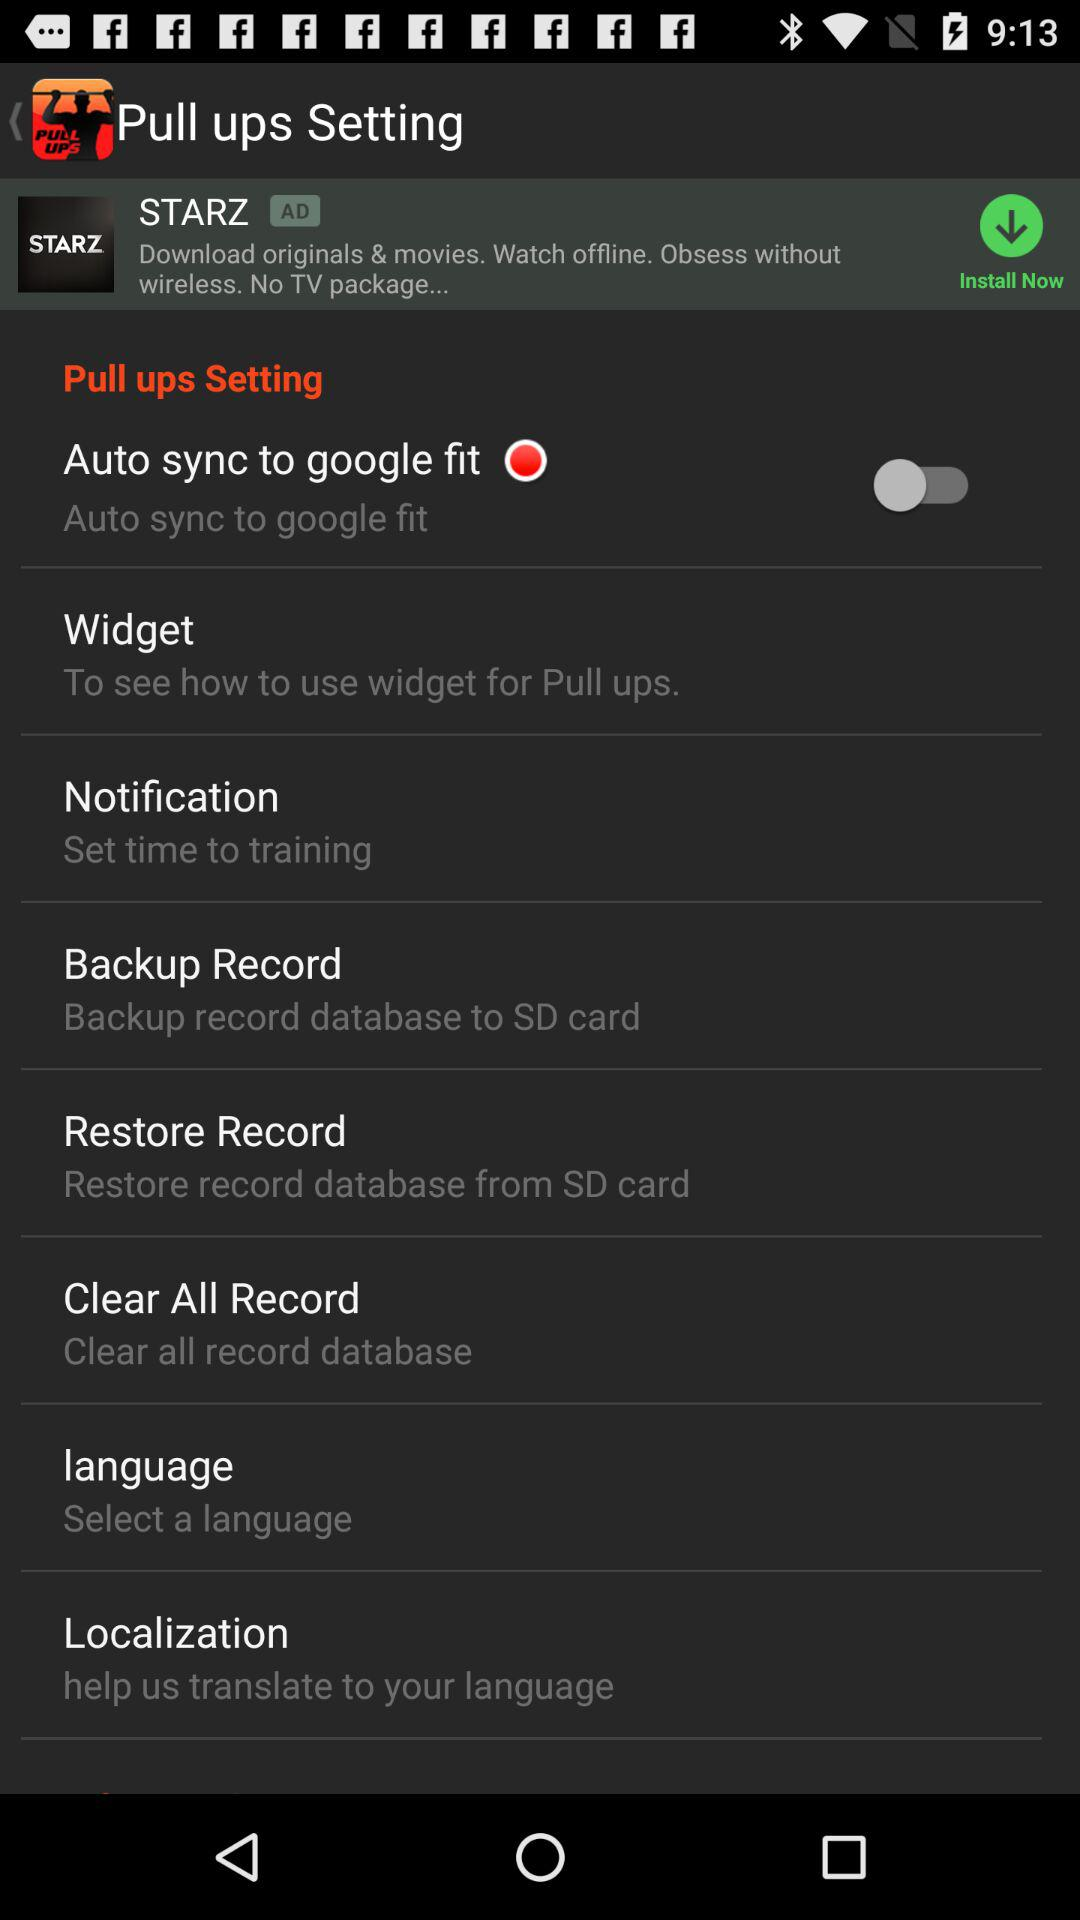From where to restore the record database? It can be restored from the SD card. 